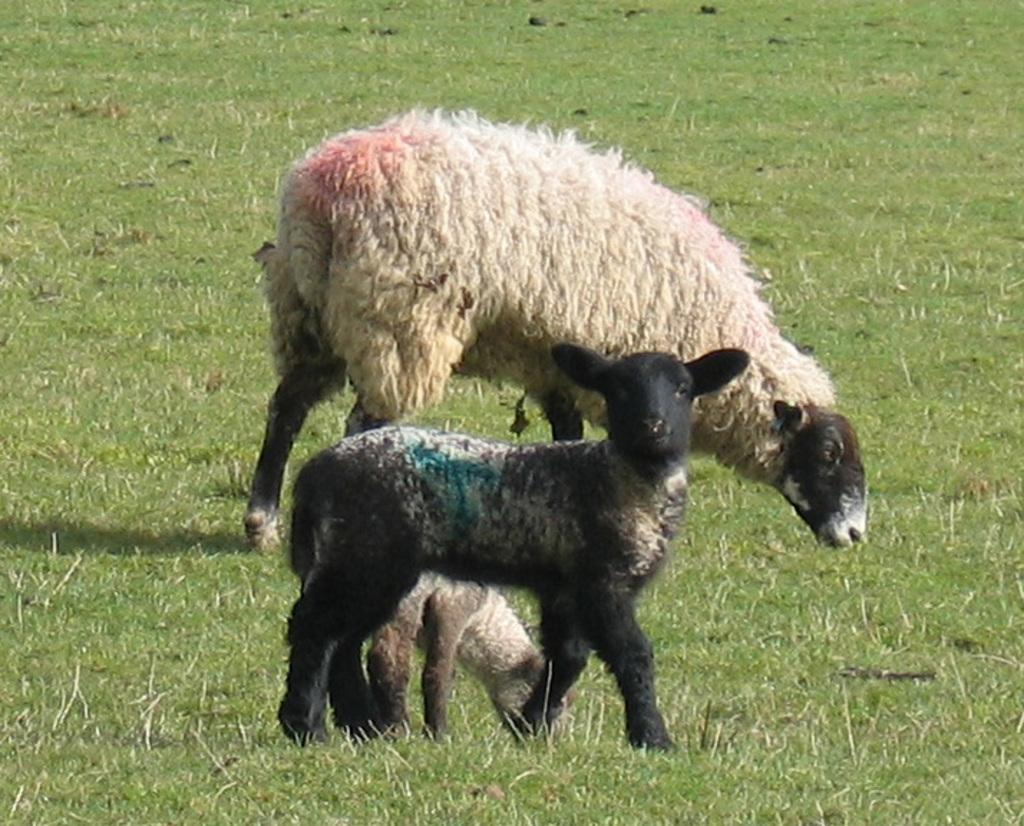How many animals are present in the image? There are three sheep in the image. What is the position of the sheep in the image? The sheep are on the ground. What type of vegetation can be seen in the image? There is grass visible in the image. What type of force is being applied to the pig in the image? There is no pig present in the image, so no force is being applied to a pig. 